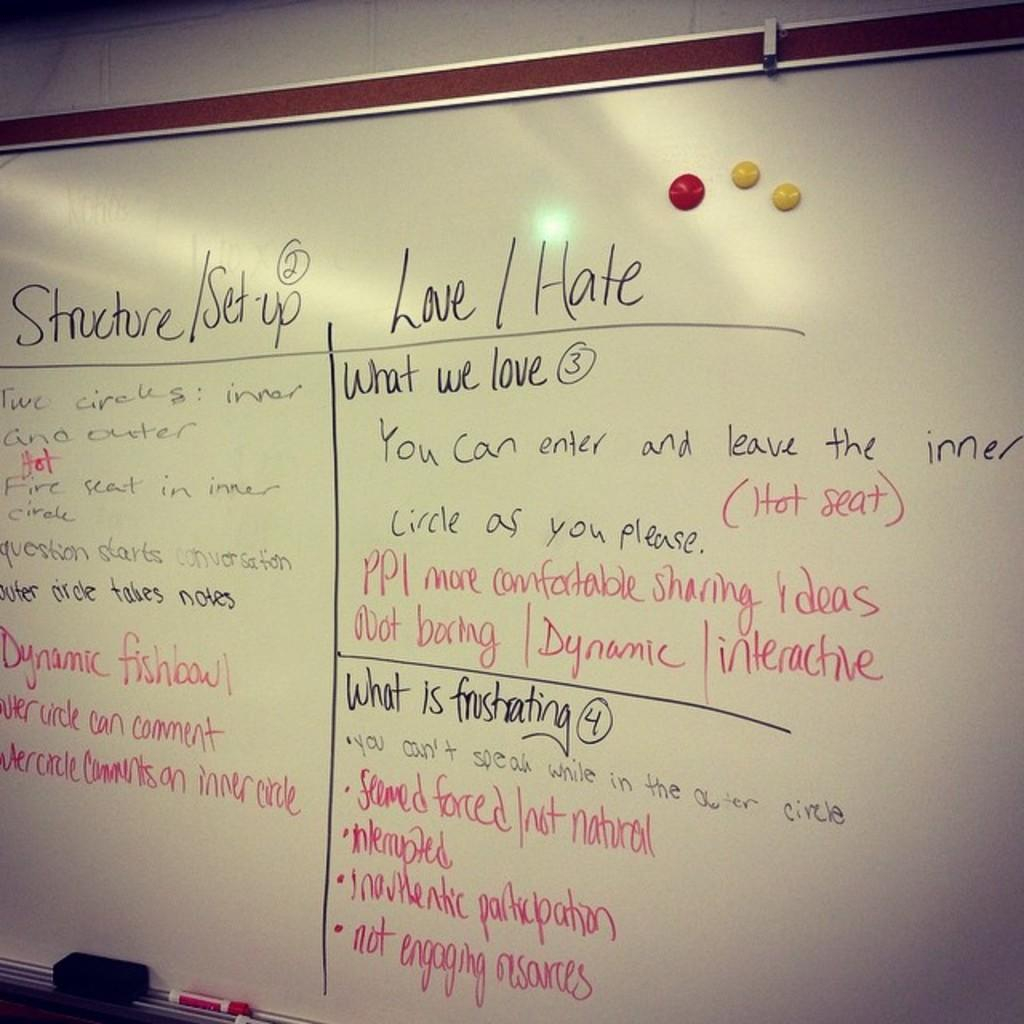<image>
Write a terse but informative summary of the picture. the words love and hate on a white board 